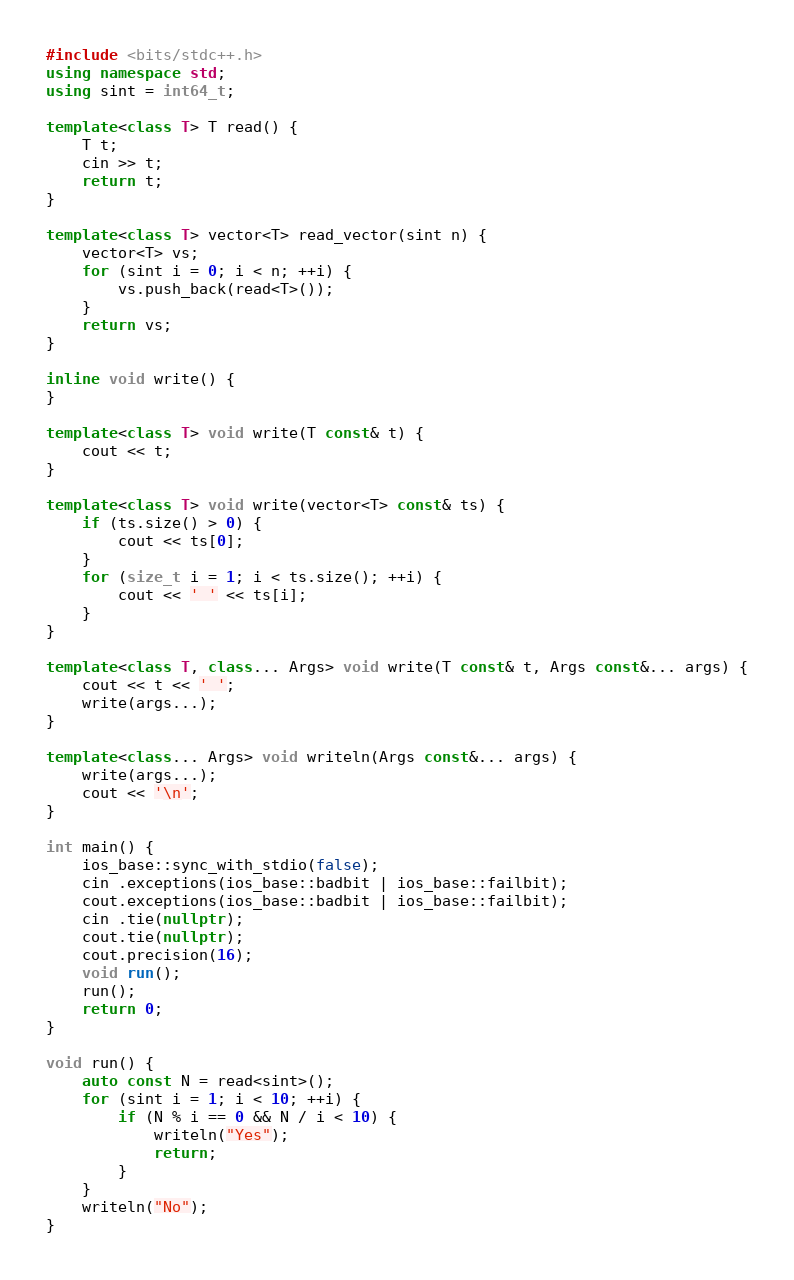Convert code to text. <code><loc_0><loc_0><loc_500><loc_500><_C++_>#include <bits/stdc++.h>
using namespace std;
using sint = int64_t;

template<class T> T read() {
	T t;
	cin >> t;
	return t;
}

template<class T> vector<T> read_vector(sint n) {
	vector<T> vs;
	for (sint i = 0; i < n; ++i) {
		vs.push_back(read<T>());
	}
	return vs;
}

inline void write() {
}

template<class T> void write(T const& t) {
	cout << t;
}

template<class T> void write(vector<T> const& ts) {
	if (ts.size() > 0) {
		cout << ts[0];
	}
	for (size_t i = 1; i < ts.size(); ++i) {
		cout << ' ' << ts[i];
	}
}

template<class T, class... Args> void write(T const& t, Args const&... args) {
	cout << t << ' ';
	write(args...);
}

template<class... Args> void writeln(Args const&... args) {
	write(args...);
	cout << '\n';
}

int main() {
	ios_base::sync_with_stdio(false);
	cin .exceptions(ios_base::badbit | ios_base::failbit);
	cout.exceptions(ios_base::badbit | ios_base::failbit);
	cin .tie(nullptr);
	cout.tie(nullptr);
	cout.precision(16);
	void run();
	run();
	return 0;
}

void run() {
	auto const N = read<sint>();
	for (sint i = 1; i < 10; ++i) {
		if (N % i == 0 && N / i < 10) {
			writeln("Yes");
			return;
		}
	}
	writeln("No");
}</code> 